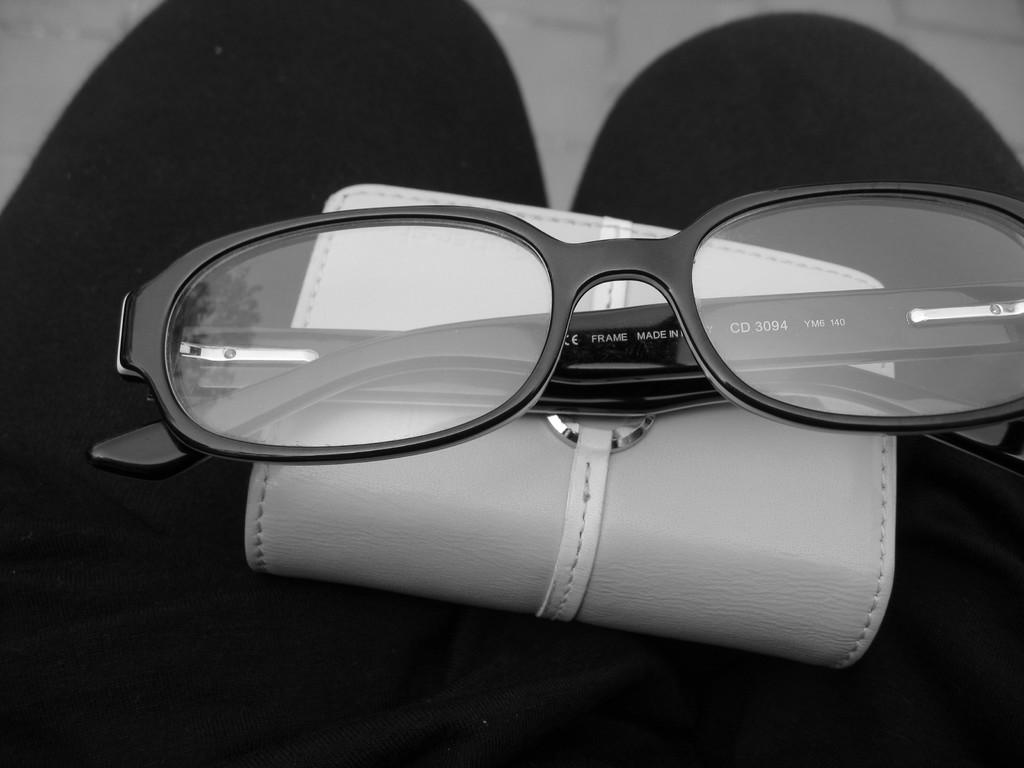What is the color scheme of the image? The image is black and white. What part of a person can be seen in the image? There are legs visible in the image. What accessory is placed on the legs? Goggles are placed on the legs. What personal item is placed on the legs? A wallet is placed on the legs. What theory is being discussed by the visitor in the alley in the image? There is no visitor or alley present in the image; it only features a person's legs with goggles and a wallet. 